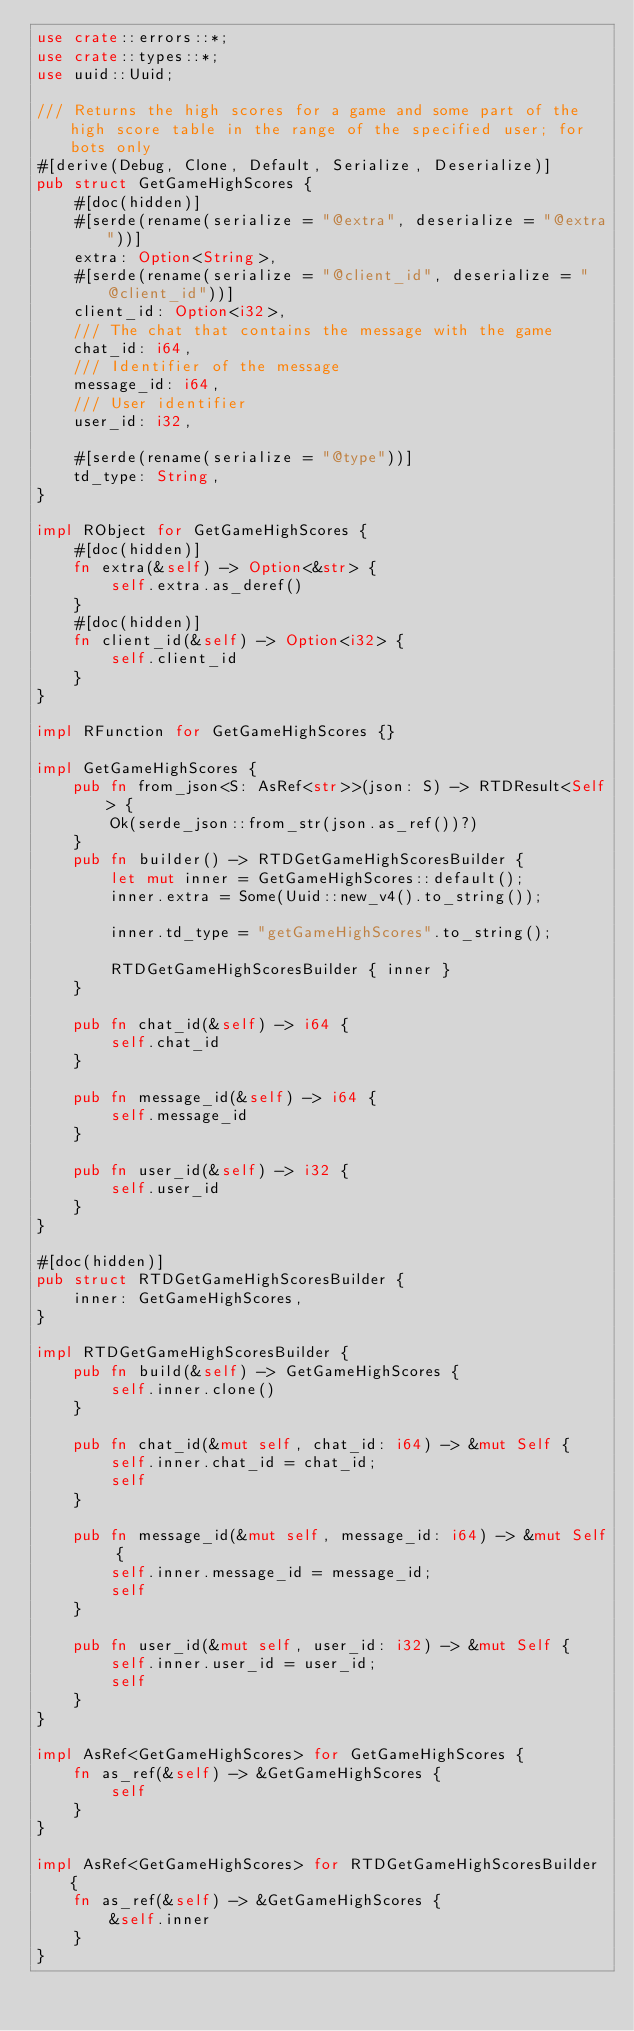<code> <loc_0><loc_0><loc_500><loc_500><_Rust_>use crate::errors::*;
use crate::types::*;
use uuid::Uuid;

/// Returns the high scores for a game and some part of the high score table in the range of the specified user; for bots only
#[derive(Debug, Clone, Default, Serialize, Deserialize)]
pub struct GetGameHighScores {
    #[doc(hidden)]
    #[serde(rename(serialize = "@extra", deserialize = "@extra"))]
    extra: Option<String>,
    #[serde(rename(serialize = "@client_id", deserialize = "@client_id"))]
    client_id: Option<i32>,
    /// The chat that contains the message with the game
    chat_id: i64,
    /// Identifier of the message
    message_id: i64,
    /// User identifier
    user_id: i32,

    #[serde(rename(serialize = "@type"))]
    td_type: String,
}

impl RObject for GetGameHighScores {
    #[doc(hidden)]
    fn extra(&self) -> Option<&str> {
        self.extra.as_deref()
    }
    #[doc(hidden)]
    fn client_id(&self) -> Option<i32> {
        self.client_id
    }
}

impl RFunction for GetGameHighScores {}

impl GetGameHighScores {
    pub fn from_json<S: AsRef<str>>(json: S) -> RTDResult<Self> {
        Ok(serde_json::from_str(json.as_ref())?)
    }
    pub fn builder() -> RTDGetGameHighScoresBuilder {
        let mut inner = GetGameHighScores::default();
        inner.extra = Some(Uuid::new_v4().to_string());

        inner.td_type = "getGameHighScores".to_string();

        RTDGetGameHighScoresBuilder { inner }
    }

    pub fn chat_id(&self) -> i64 {
        self.chat_id
    }

    pub fn message_id(&self) -> i64 {
        self.message_id
    }

    pub fn user_id(&self) -> i32 {
        self.user_id
    }
}

#[doc(hidden)]
pub struct RTDGetGameHighScoresBuilder {
    inner: GetGameHighScores,
}

impl RTDGetGameHighScoresBuilder {
    pub fn build(&self) -> GetGameHighScores {
        self.inner.clone()
    }

    pub fn chat_id(&mut self, chat_id: i64) -> &mut Self {
        self.inner.chat_id = chat_id;
        self
    }

    pub fn message_id(&mut self, message_id: i64) -> &mut Self {
        self.inner.message_id = message_id;
        self
    }

    pub fn user_id(&mut self, user_id: i32) -> &mut Self {
        self.inner.user_id = user_id;
        self
    }
}

impl AsRef<GetGameHighScores> for GetGameHighScores {
    fn as_ref(&self) -> &GetGameHighScores {
        self
    }
}

impl AsRef<GetGameHighScores> for RTDGetGameHighScoresBuilder {
    fn as_ref(&self) -> &GetGameHighScores {
        &self.inner
    }
}
</code> 